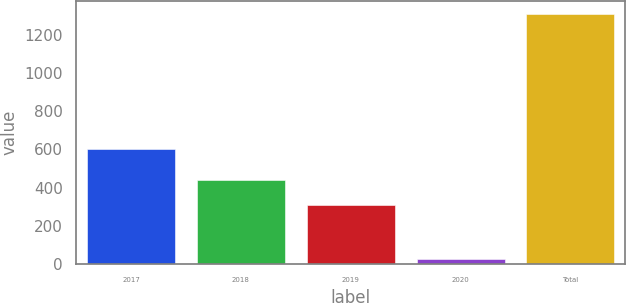Convert chart. <chart><loc_0><loc_0><loc_500><loc_500><bar_chart><fcel>2017<fcel>2018<fcel>2019<fcel>2020<fcel>Total<nl><fcel>599<fcel>439.1<fcel>311<fcel>27<fcel>1308<nl></chart> 